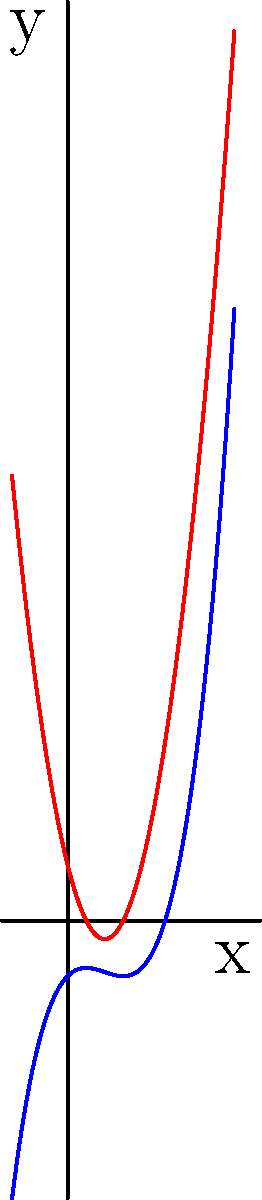Given the polynomial functions $f(x) = x^3 - 2x^2 + x - 1$ and $g(x) = 3x^2 - 4x + 1$ used in a large-scale AI application, which JavaScript optimization technique would be most effective for calculating these polynomials efficiently for a large number of input values? To optimize polynomial calculations for large-scale AI applications using JavaScript, we need to consider the following steps:

1. Analyze the polynomials:
   $f(x) = x^3 - 2x^2 + x - 1$
   $g(x) = 3x^2 - 4x + 1$

2. Recognize that these polynomials involve repeated calculations of powers of x.

3. Consider the optimization techniques available in JavaScript:
   a) Memoization
   b) Horner's method
   c) Vectorization
   d) Web Workers

4. Evaluate each technique:
   a) Memoization: Useful for repeated calculations with the same input, but not ideal for varying inputs.
   b) Horner's method: Efficient for evaluating polynomials with fewer multiplications.
   c) Vectorization: Beneficial for parallel processing of multiple inputs.
   d) Web Workers: Good for offloading complex calculations to background threads.

5. Choose the most effective technique:
   Horner's method is the most suitable for this scenario because:
   - It reduces the number of multiplications required.
   - It's particularly efficient for polynomials of any degree.
   - It can be easily implemented in JavaScript.

6. Apply Horner's method:
   For $f(x) = x^3 - 2x^2 + x - 1$, rewrite as:
   $f(x) = ((x - 2)x + 1)x - 1$

   For $g(x) = 3x^2 - 4x + 1$, rewrite as:
   $g(x) = (3x - 4)x + 1$

7. Implement in JavaScript:
   ```javascript
   function evaluateF(x) {
     return ((x - 2) * x + 1) * x - 1;
   }

   function evaluateG(x) {
     return (3 * x - 4) * x + 1;
   }
   ```

This implementation using Horner's method reduces the number of multiplications and is more efficient for large-scale calculations.
Answer: Horner's method 